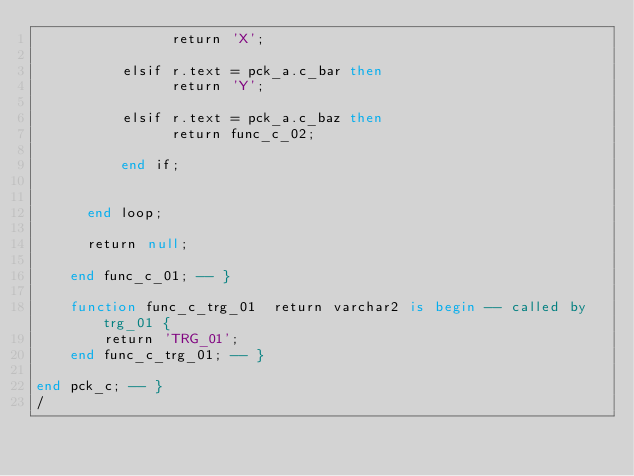<code> <loc_0><loc_0><loc_500><loc_500><_SQL_>                return 'X';

          elsif r.text = pck_a.c_bar then
                return 'Y';

          elsif r.text = pck_a.c_baz then
                return func_c_02;

          end if;


      end loop;

      return null;

    end func_c_01; -- }

    function func_c_trg_01  return varchar2 is begin -- called by trg_01 {
        return 'TRG_01';
    end func_c_trg_01; -- }

end pck_c; -- }
/
</code> 